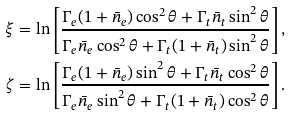<formula> <loc_0><loc_0><loc_500><loc_500>\xi & = \ln { \left [ \frac { \Gamma _ { e } ( 1 + \bar { n } _ { e } ) \cos ^ { 2 } { \theta } + \Gamma _ { t } \bar { n } _ { t } \sin ^ { 2 } { \theta } } { \Gamma _ { e } \bar { n } _ { e } \cos ^ { 2 } { \theta } + \Gamma _ { t } ( 1 + \bar { n } _ { t } ) \sin ^ { 2 } { \theta } } \right ] } \, , \\ \zeta & = \ln { \left [ \frac { \Gamma _ { e } ( 1 + \bar { n } _ { e } ) \sin ^ { 2 } { \theta } + \Gamma _ { t } \bar { n } _ { t } \cos ^ { 2 } { \theta } } { \Gamma _ { e } \bar { n } _ { e } \sin ^ { 2 } { \theta } + \Gamma _ { t } ( 1 + \bar { n } _ { t } ) \cos ^ { 2 } { \theta } } \right ] } \, .</formula> 